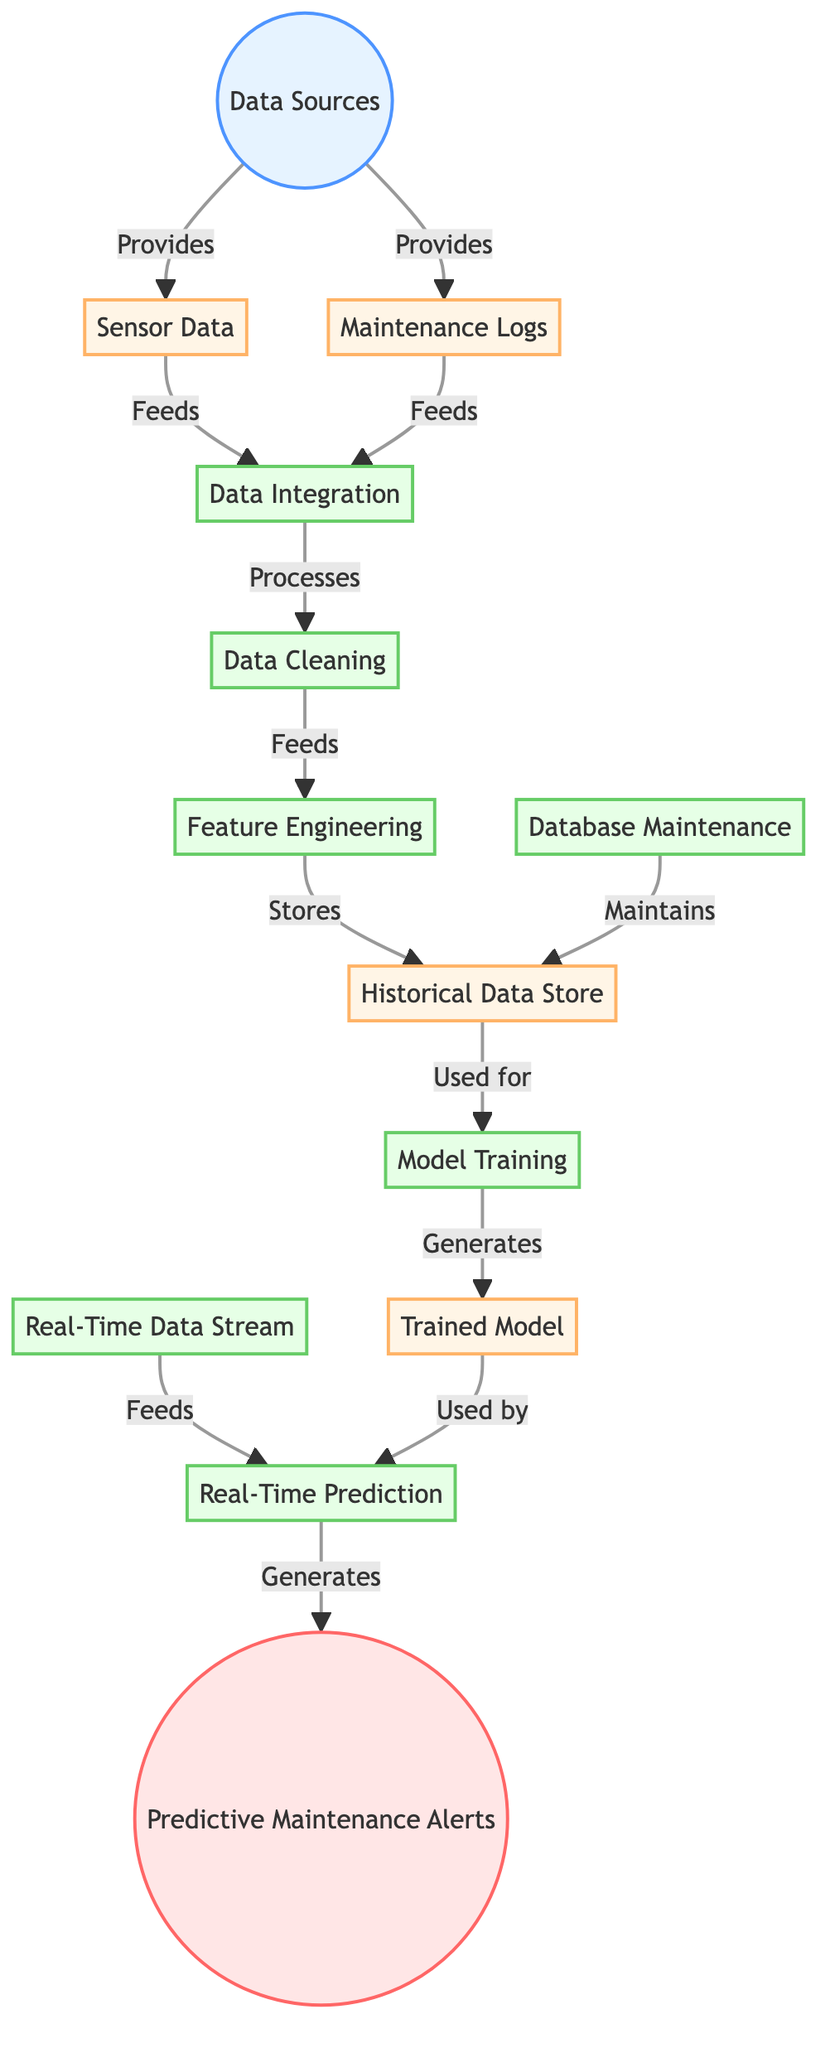What are the two main inputs to the data integration process? The inputs are sensor data and maintenance logs, which both feed into the data integration process.
Answer: sensor data, maintenance logs How many processes are involved in the diagram? There are five processes: data integration, data cleaning, feature engineering, model training, and real-time prediction.
Answer: five processes What is generated as the final output of the diagram? The final output generated is predictive maintenance alerts.
Answer: predictive maintenance alerts Which data source is used for model training? The historical data store is used for model training according to the flow of data in the diagram.
Answer: historical data store What feeds into the real-time prediction process? The real-time prediction process is fed by the real-time stream and the trained model.
Answer: real-time stream, trained model What maintains the historical data store? Database maintenance maintains the historical data store as indicated in the diagram.
Answer: database maintenance How does the feature engineering process store its output? Feature engineering stores its output in the historical data store, which can then be used for model training.
Answer: historical data store What directly feeds into the data cleaning process? The data cleaning process is directly fed by the data integration output.
Answer: data integration What does the trained model generate? The trained model generates real-time predictions as per the flow in the diagram.
Answer: real-time predictions 